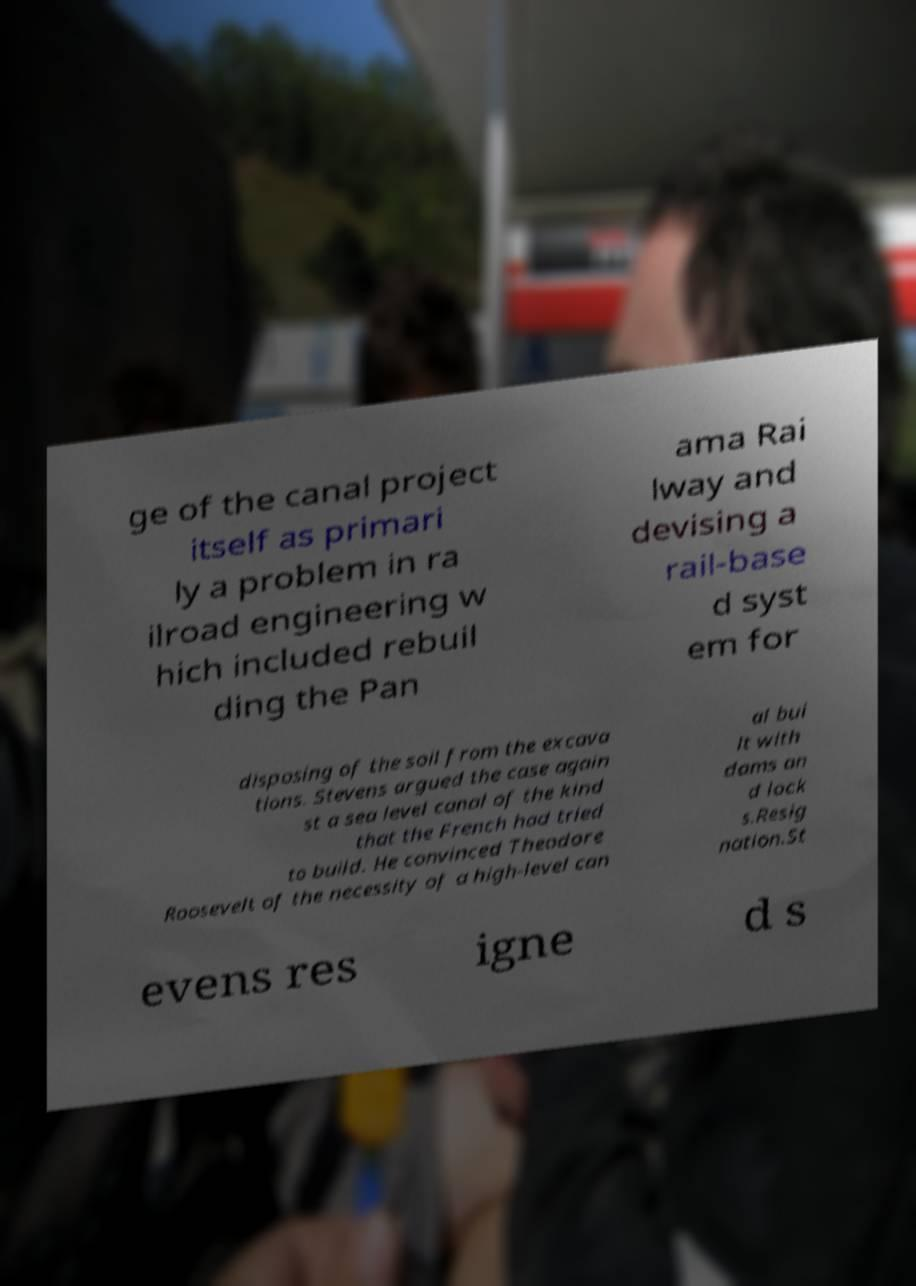Could you extract and type out the text from this image? ge of the canal project itself as primari ly a problem in ra ilroad engineering w hich included rebuil ding the Pan ama Rai lway and devising a rail-base d syst em for disposing of the soil from the excava tions. Stevens argued the case again st a sea level canal of the kind that the French had tried to build. He convinced Theodore Roosevelt of the necessity of a high-level can al bui lt with dams an d lock s.Resig nation.St evens res igne d s 